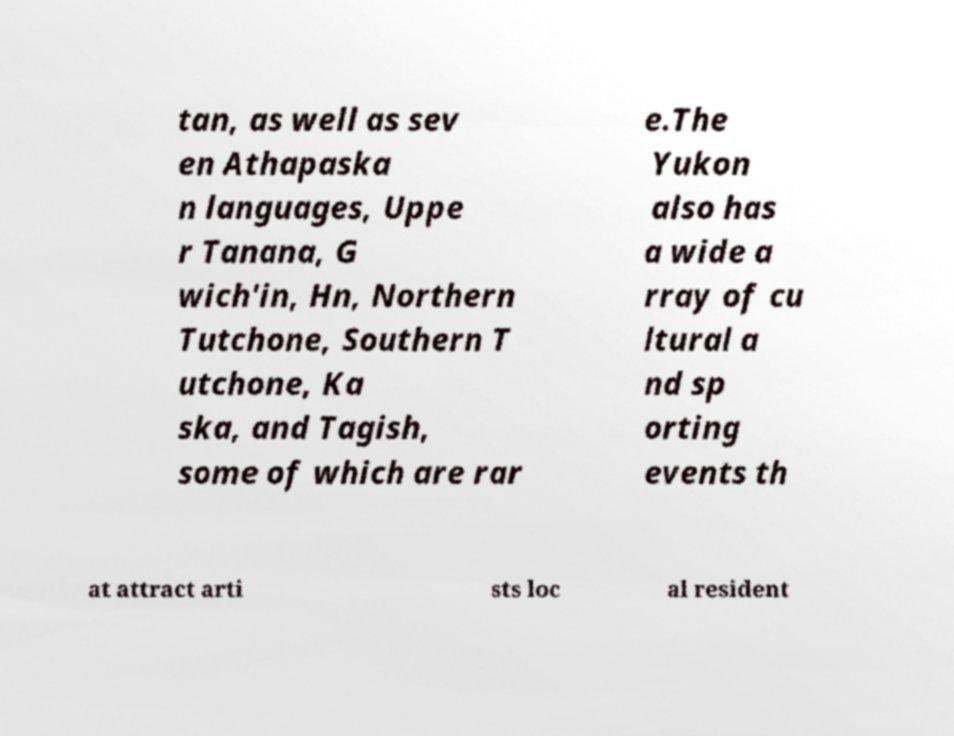I need the written content from this picture converted into text. Can you do that? tan, as well as sev en Athapaska n languages, Uppe r Tanana, G wich'in, Hn, Northern Tutchone, Southern T utchone, Ka ska, and Tagish, some of which are rar e.The Yukon also has a wide a rray of cu ltural a nd sp orting events th at attract arti sts loc al resident 